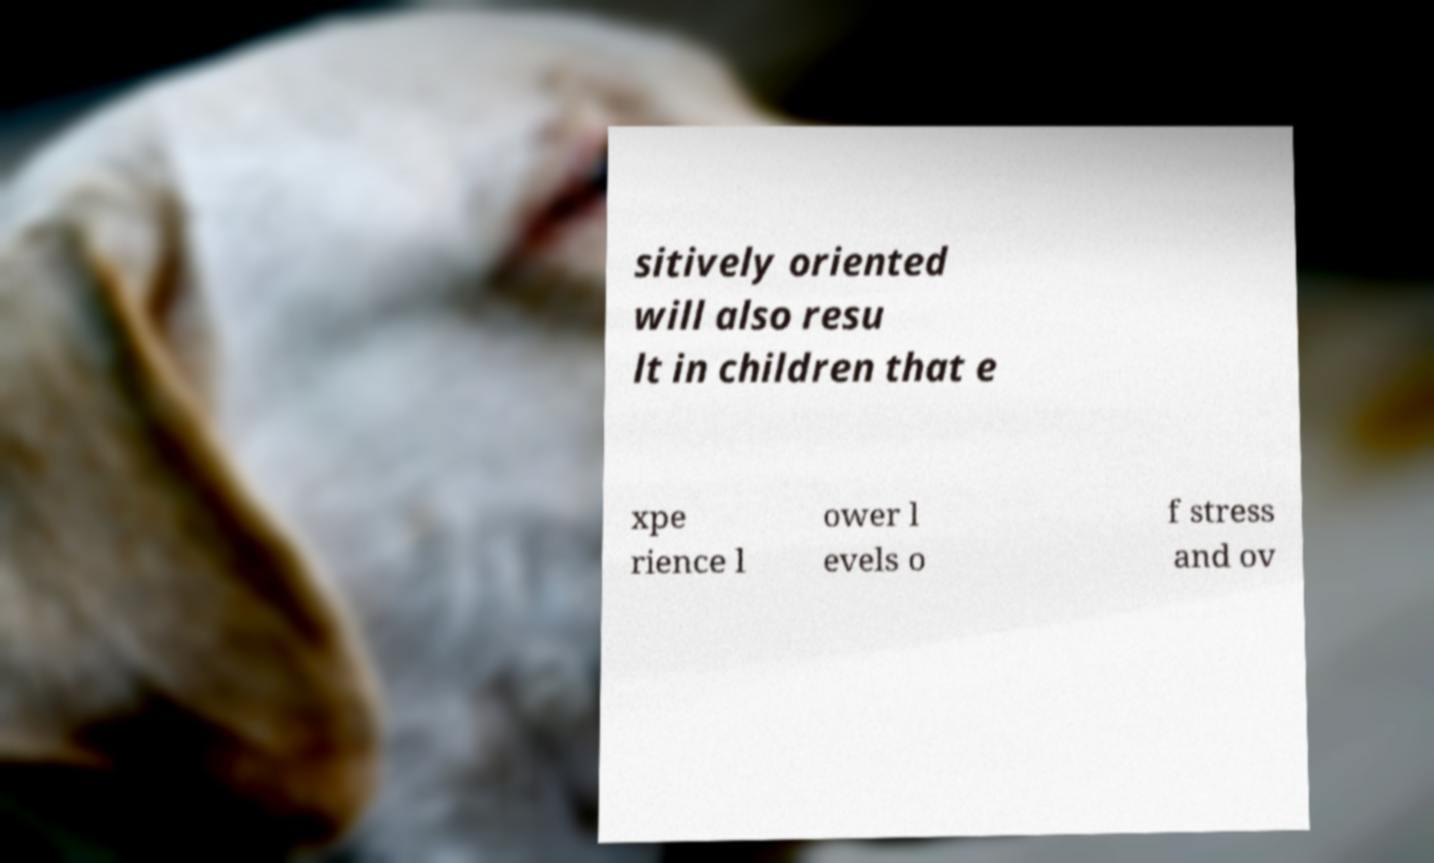For documentation purposes, I need the text within this image transcribed. Could you provide that? sitively oriented will also resu lt in children that e xpe rience l ower l evels o f stress and ov 